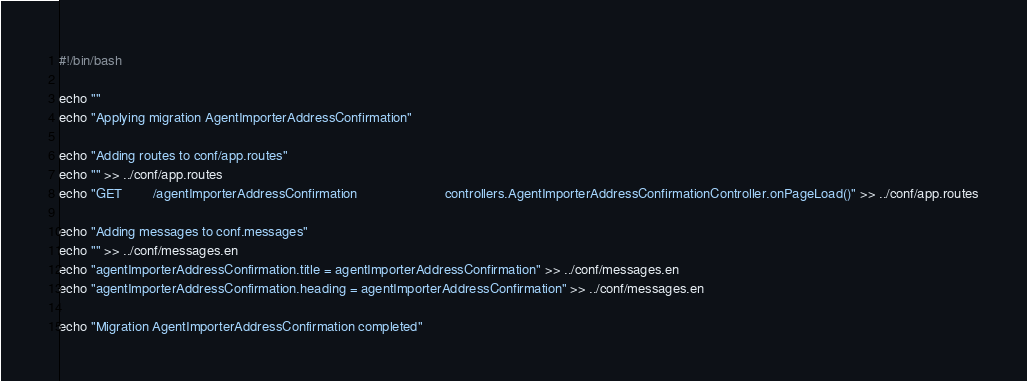Convert code to text. <code><loc_0><loc_0><loc_500><loc_500><_Bash_>#!/bin/bash

echo ""
echo "Applying migration AgentImporterAddressConfirmation"

echo "Adding routes to conf/app.routes"
echo "" >> ../conf/app.routes
echo "GET        /agentImporterAddressConfirmation                       controllers.AgentImporterAddressConfirmationController.onPageLoad()" >> ../conf/app.routes

echo "Adding messages to conf.messages"
echo "" >> ../conf/messages.en
echo "agentImporterAddressConfirmation.title = agentImporterAddressConfirmation" >> ../conf/messages.en
echo "agentImporterAddressConfirmation.heading = agentImporterAddressConfirmation" >> ../conf/messages.en

echo "Migration AgentImporterAddressConfirmation completed"
</code> 